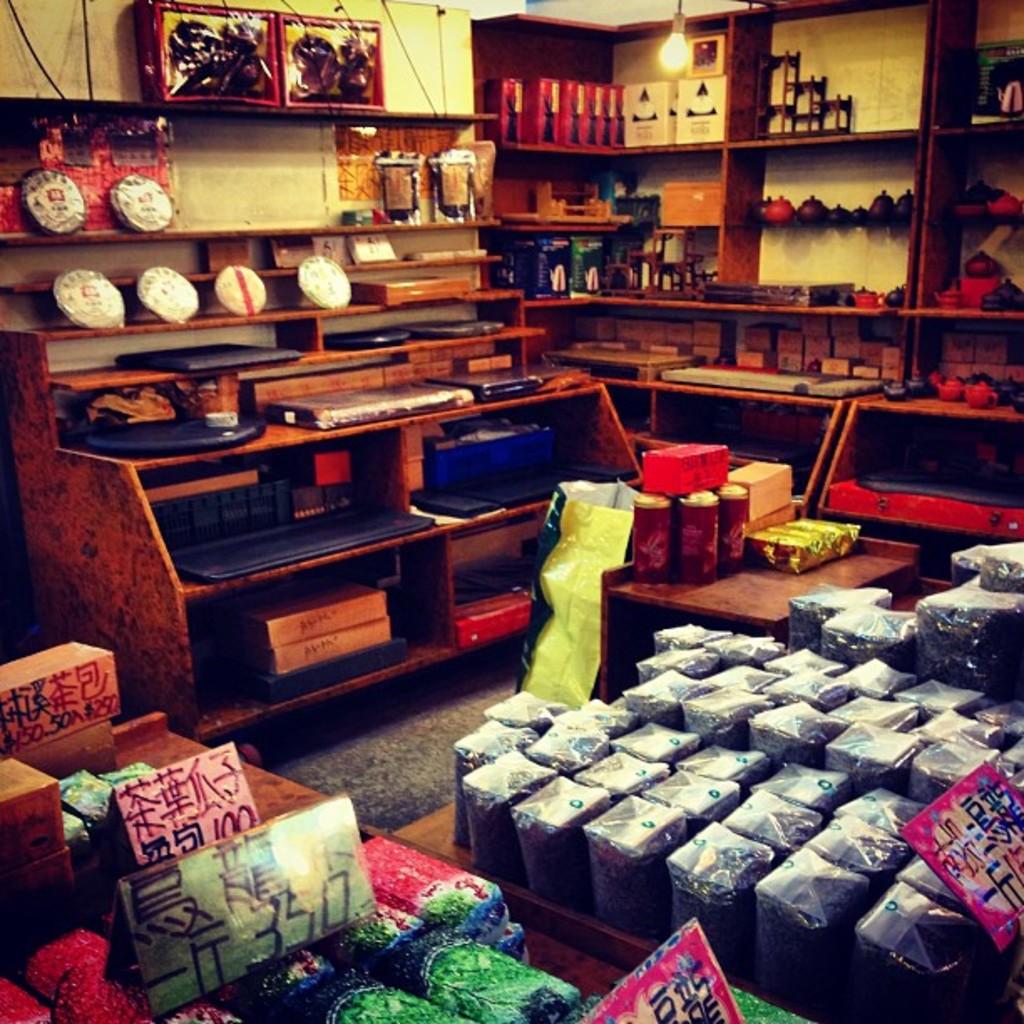How much are those?
Provide a short and direct response. Unanswerable. 